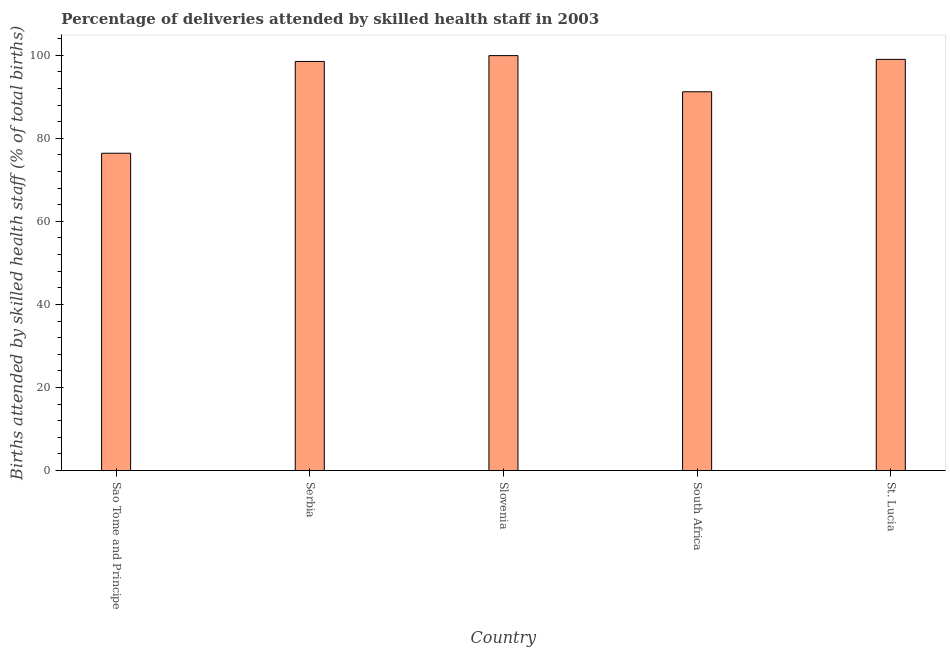Does the graph contain any zero values?
Provide a succinct answer. No. What is the title of the graph?
Offer a very short reply. Percentage of deliveries attended by skilled health staff in 2003. What is the label or title of the Y-axis?
Provide a short and direct response. Births attended by skilled health staff (% of total births). What is the number of births attended by skilled health staff in St. Lucia?
Offer a terse response. 99. Across all countries, what is the maximum number of births attended by skilled health staff?
Your answer should be very brief. 99.9. Across all countries, what is the minimum number of births attended by skilled health staff?
Give a very brief answer. 76.4. In which country was the number of births attended by skilled health staff maximum?
Offer a terse response. Slovenia. In which country was the number of births attended by skilled health staff minimum?
Your answer should be compact. Sao Tome and Principe. What is the sum of the number of births attended by skilled health staff?
Your answer should be compact. 465. What is the difference between the number of births attended by skilled health staff in Serbia and South Africa?
Your response must be concise. 7.3. What is the average number of births attended by skilled health staff per country?
Your answer should be compact. 93. What is the median number of births attended by skilled health staff?
Your answer should be compact. 98.5. What is the ratio of the number of births attended by skilled health staff in Sao Tome and Principe to that in Slovenia?
Make the answer very short. 0.77. Is the number of births attended by skilled health staff in Serbia less than that in South Africa?
Provide a short and direct response. No. Is the difference between the number of births attended by skilled health staff in Sao Tome and Principe and Serbia greater than the difference between any two countries?
Provide a short and direct response. No. What is the difference between the highest and the second highest number of births attended by skilled health staff?
Your response must be concise. 0.9. What is the difference between the highest and the lowest number of births attended by skilled health staff?
Your response must be concise. 23.5. In how many countries, is the number of births attended by skilled health staff greater than the average number of births attended by skilled health staff taken over all countries?
Keep it short and to the point. 3. Are all the bars in the graph horizontal?
Provide a short and direct response. No. How many countries are there in the graph?
Give a very brief answer. 5. What is the difference between two consecutive major ticks on the Y-axis?
Your response must be concise. 20. What is the Births attended by skilled health staff (% of total births) in Sao Tome and Principe?
Your answer should be very brief. 76.4. What is the Births attended by skilled health staff (% of total births) of Serbia?
Offer a terse response. 98.5. What is the Births attended by skilled health staff (% of total births) in Slovenia?
Your answer should be very brief. 99.9. What is the Births attended by skilled health staff (% of total births) in South Africa?
Offer a very short reply. 91.2. What is the difference between the Births attended by skilled health staff (% of total births) in Sao Tome and Principe and Serbia?
Your answer should be compact. -22.1. What is the difference between the Births attended by skilled health staff (% of total births) in Sao Tome and Principe and Slovenia?
Make the answer very short. -23.5. What is the difference between the Births attended by skilled health staff (% of total births) in Sao Tome and Principe and South Africa?
Your response must be concise. -14.8. What is the difference between the Births attended by skilled health staff (% of total births) in Sao Tome and Principe and St. Lucia?
Your answer should be very brief. -22.6. What is the difference between the Births attended by skilled health staff (% of total births) in Serbia and South Africa?
Your answer should be very brief. 7.3. What is the difference between the Births attended by skilled health staff (% of total births) in Serbia and St. Lucia?
Provide a short and direct response. -0.5. What is the difference between the Births attended by skilled health staff (% of total births) in South Africa and St. Lucia?
Ensure brevity in your answer.  -7.8. What is the ratio of the Births attended by skilled health staff (% of total births) in Sao Tome and Principe to that in Serbia?
Provide a short and direct response. 0.78. What is the ratio of the Births attended by skilled health staff (% of total births) in Sao Tome and Principe to that in Slovenia?
Offer a terse response. 0.77. What is the ratio of the Births attended by skilled health staff (% of total births) in Sao Tome and Principe to that in South Africa?
Your answer should be very brief. 0.84. What is the ratio of the Births attended by skilled health staff (% of total births) in Sao Tome and Principe to that in St. Lucia?
Give a very brief answer. 0.77. What is the ratio of the Births attended by skilled health staff (% of total births) in Serbia to that in Slovenia?
Make the answer very short. 0.99. What is the ratio of the Births attended by skilled health staff (% of total births) in Serbia to that in St. Lucia?
Offer a very short reply. 0.99. What is the ratio of the Births attended by skilled health staff (% of total births) in Slovenia to that in South Africa?
Make the answer very short. 1.09. What is the ratio of the Births attended by skilled health staff (% of total births) in Slovenia to that in St. Lucia?
Provide a succinct answer. 1.01. What is the ratio of the Births attended by skilled health staff (% of total births) in South Africa to that in St. Lucia?
Your answer should be very brief. 0.92. 